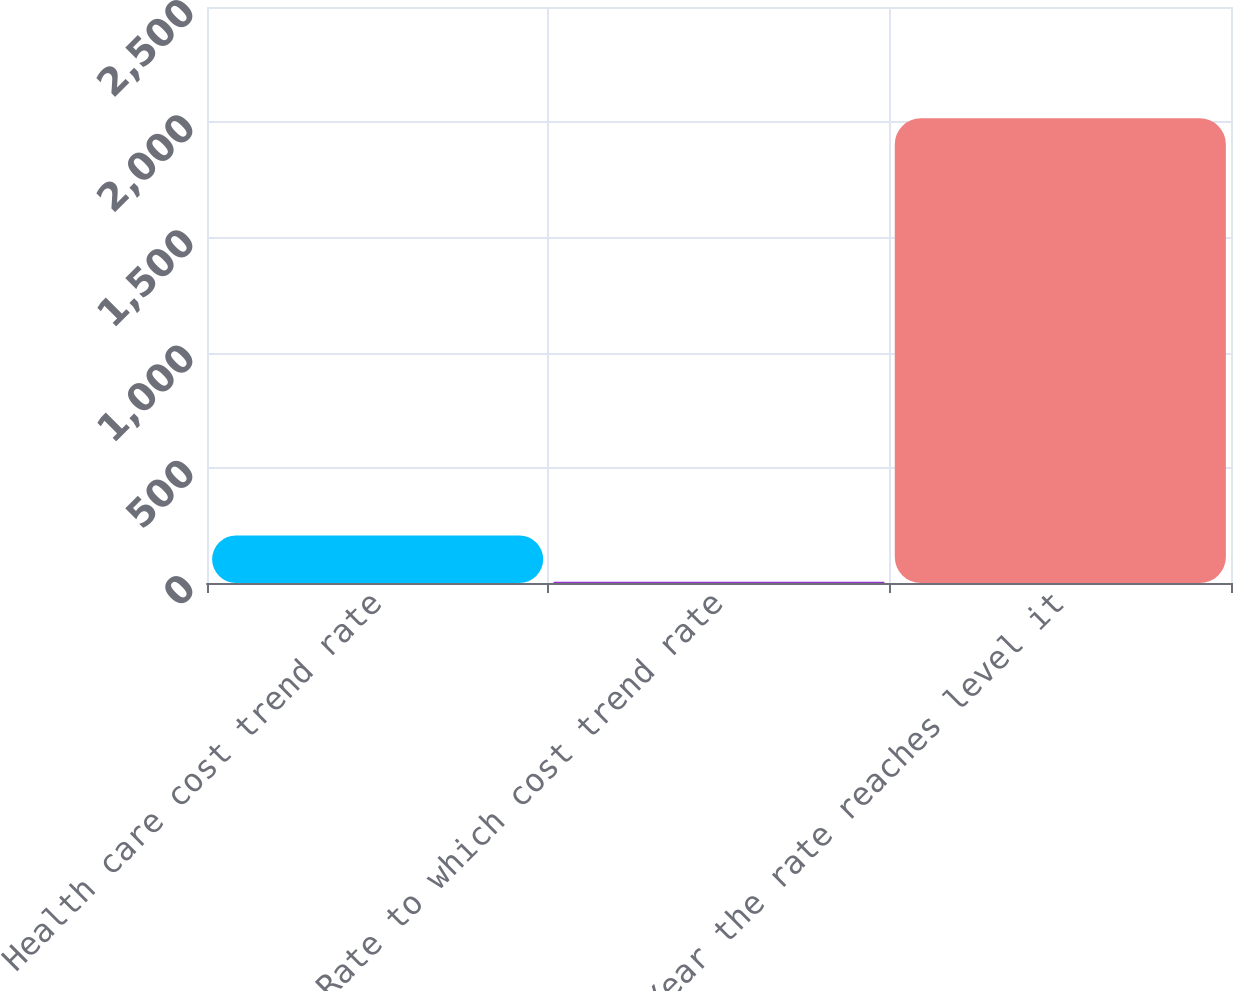<chart> <loc_0><loc_0><loc_500><loc_500><bar_chart><fcel>Health care cost trend rate<fcel>Rate to which cost trend rate<fcel>Year the rate reaches level it<nl><fcel>206.2<fcel>5<fcel>2017<nl></chart> 